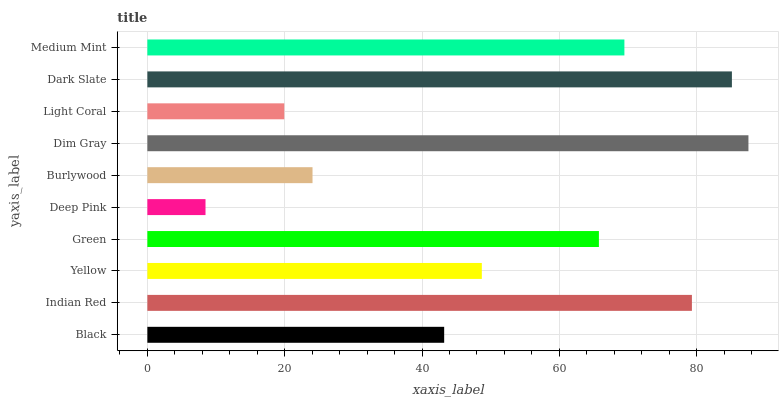Is Deep Pink the minimum?
Answer yes or no. Yes. Is Dim Gray the maximum?
Answer yes or no. Yes. Is Indian Red the minimum?
Answer yes or no. No. Is Indian Red the maximum?
Answer yes or no. No. Is Indian Red greater than Black?
Answer yes or no. Yes. Is Black less than Indian Red?
Answer yes or no. Yes. Is Black greater than Indian Red?
Answer yes or no. No. Is Indian Red less than Black?
Answer yes or no. No. Is Green the high median?
Answer yes or no. Yes. Is Yellow the low median?
Answer yes or no. Yes. Is Burlywood the high median?
Answer yes or no. No. Is Deep Pink the low median?
Answer yes or no. No. 